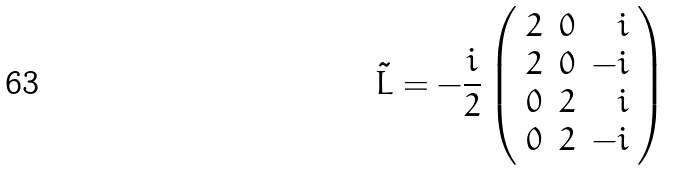Convert formula to latex. <formula><loc_0><loc_0><loc_500><loc_500>\tilde { L } = - \frac { i } { 2 } \left ( \begin{array} { r r r } 2 & 0 & i \\ 2 & 0 & - i \\ 0 & 2 & i \\ 0 & 2 & - i \\ \end{array} \right )</formula> 